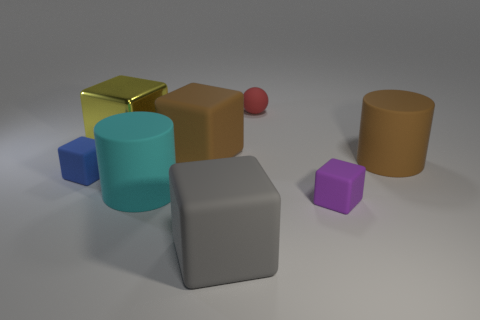Are there any other things that have the same material as the yellow object?
Ensure brevity in your answer.  No. What is the material of the cylinder that is on the left side of the large matte thing on the right side of the gray matte block?
Your response must be concise. Rubber. How many objects are either brown things on the left side of the tiny purple rubber thing or large yellow cylinders?
Keep it short and to the point. 1. Are there the same number of gray rubber cubes in front of the big gray matte cube and large brown rubber blocks on the right side of the blue cube?
Offer a very short reply. No. There is a cylinder on the left side of the tiny block that is in front of the small rubber cube to the left of the large yellow metal block; what is its material?
Give a very brief answer. Rubber. What is the size of the cube that is behind the small blue cube and on the right side of the yellow object?
Give a very brief answer. Large. Does the small purple rubber thing have the same shape as the blue matte thing?
Provide a short and direct response. Yes. There is a tiny blue thing that is the same material as the sphere; what is its shape?
Your answer should be very brief. Cube. What number of large objects are either shiny spheres or brown cylinders?
Your response must be concise. 1. Is there a small blue matte block that is on the right side of the small object that is on the right side of the matte sphere?
Make the answer very short. No. 